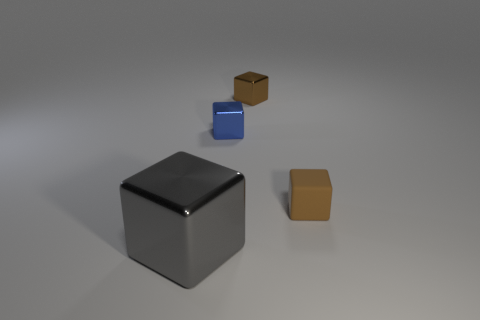Do the brown thing that is behind the matte thing and the brown rubber object have the same shape?
Offer a terse response. Yes. What is the shape of the brown object behind the thing that is right of the cube behind the small blue metal cube?
Make the answer very short. Cube. There is a tiny metal object that is the same color as the rubber thing; what shape is it?
Ensure brevity in your answer.  Cube. The small block that is to the right of the blue cube and on the left side of the small brown rubber object is made of what material?
Give a very brief answer. Metal. Are there fewer tiny rubber things than large purple shiny balls?
Your answer should be compact. No. There is a brown matte object; does it have the same shape as the tiny brown thing behind the tiny brown matte thing?
Your response must be concise. Yes. Do the object that is right of the brown metal object and the blue metallic thing have the same size?
Your answer should be very brief. Yes. There is a rubber object that is the same size as the blue metal block; what shape is it?
Your response must be concise. Cube. Does the brown metal thing have the same shape as the small brown rubber object?
Provide a short and direct response. Yes. How many small blue metallic objects have the same shape as the matte object?
Provide a succinct answer. 1. 